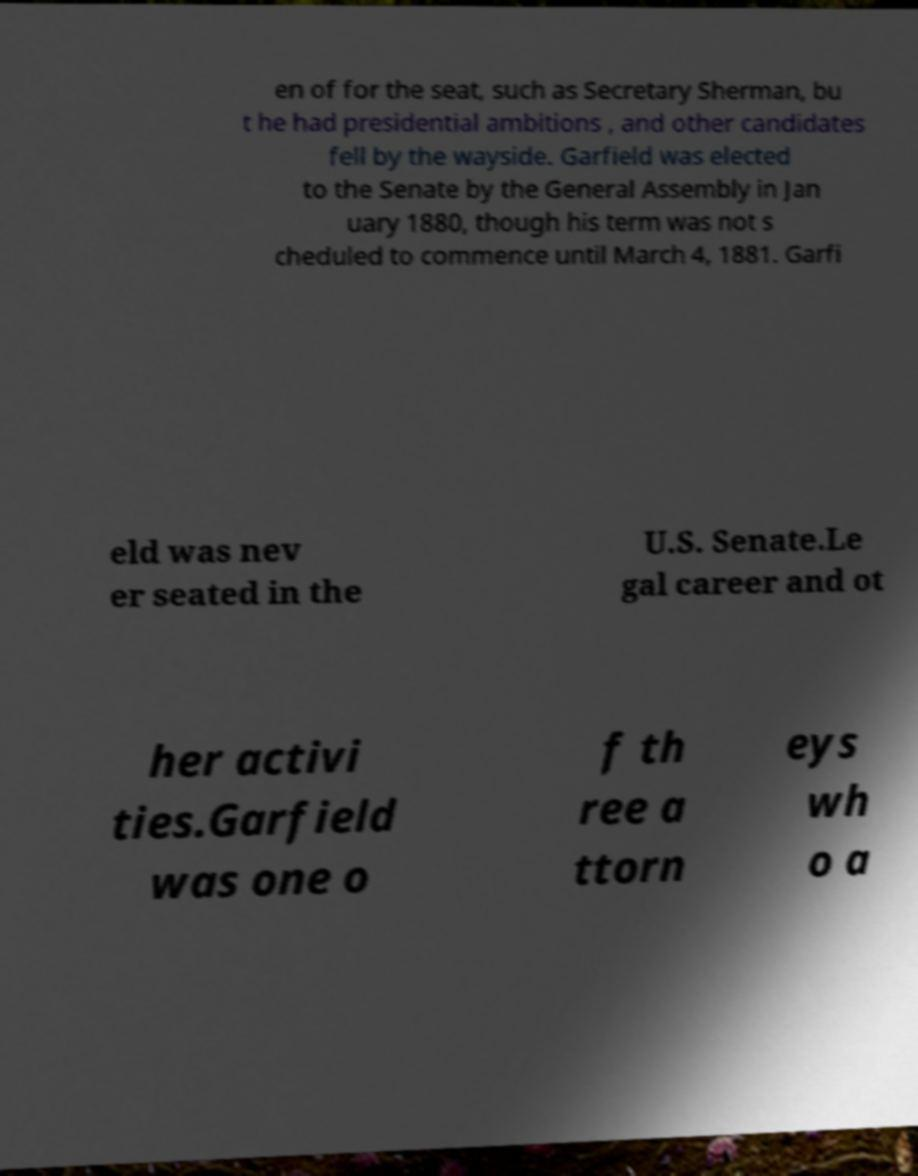Could you assist in decoding the text presented in this image and type it out clearly? en of for the seat, such as Secretary Sherman, bu t he had presidential ambitions , and other candidates fell by the wayside. Garfield was elected to the Senate by the General Assembly in Jan uary 1880, though his term was not s cheduled to commence until March 4, 1881. Garfi eld was nev er seated in the U.S. Senate.Le gal career and ot her activi ties.Garfield was one o f th ree a ttorn eys wh o a 